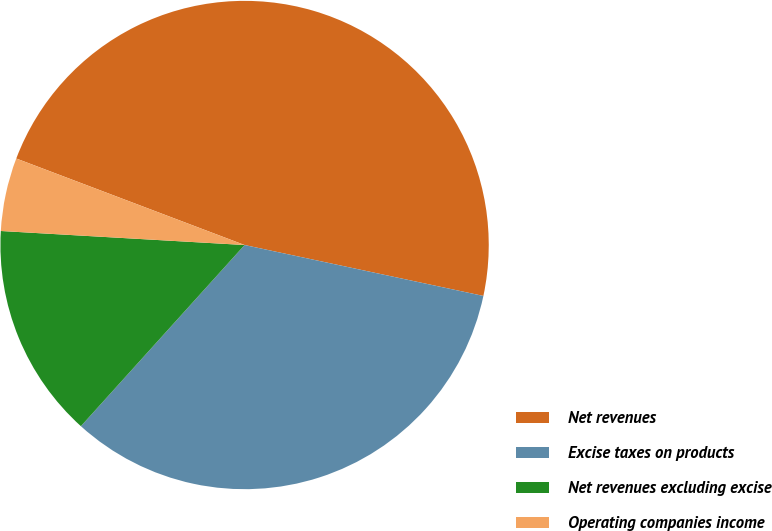Convert chart to OTSL. <chart><loc_0><loc_0><loc_500><loc_500><pie_chart><fcel>Net revenues<fcel>Excise taxes on products<fcel>Net revenues excluding excise<fcel>Operating companies income<nl><fcel>47.58%<fcel>33.35%<fcel>14.22%<fcel>4.85%<nl></chart> 